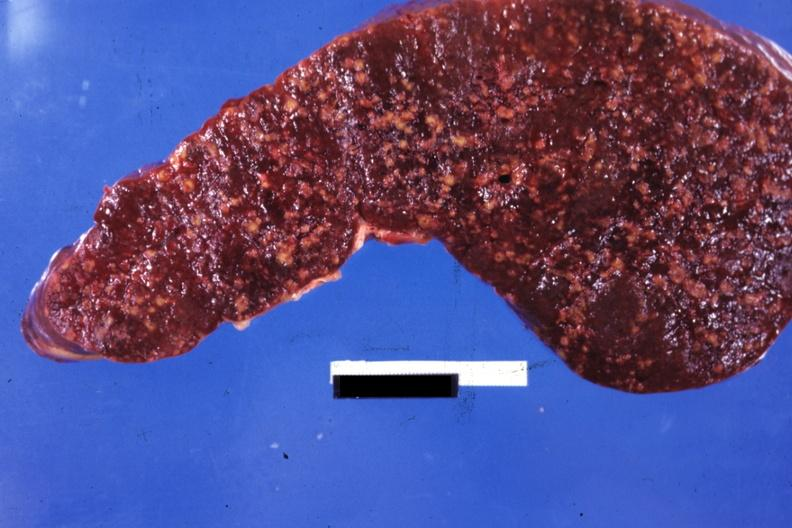s hematologic present?
Answer the question using a single word or phrase. Yes 